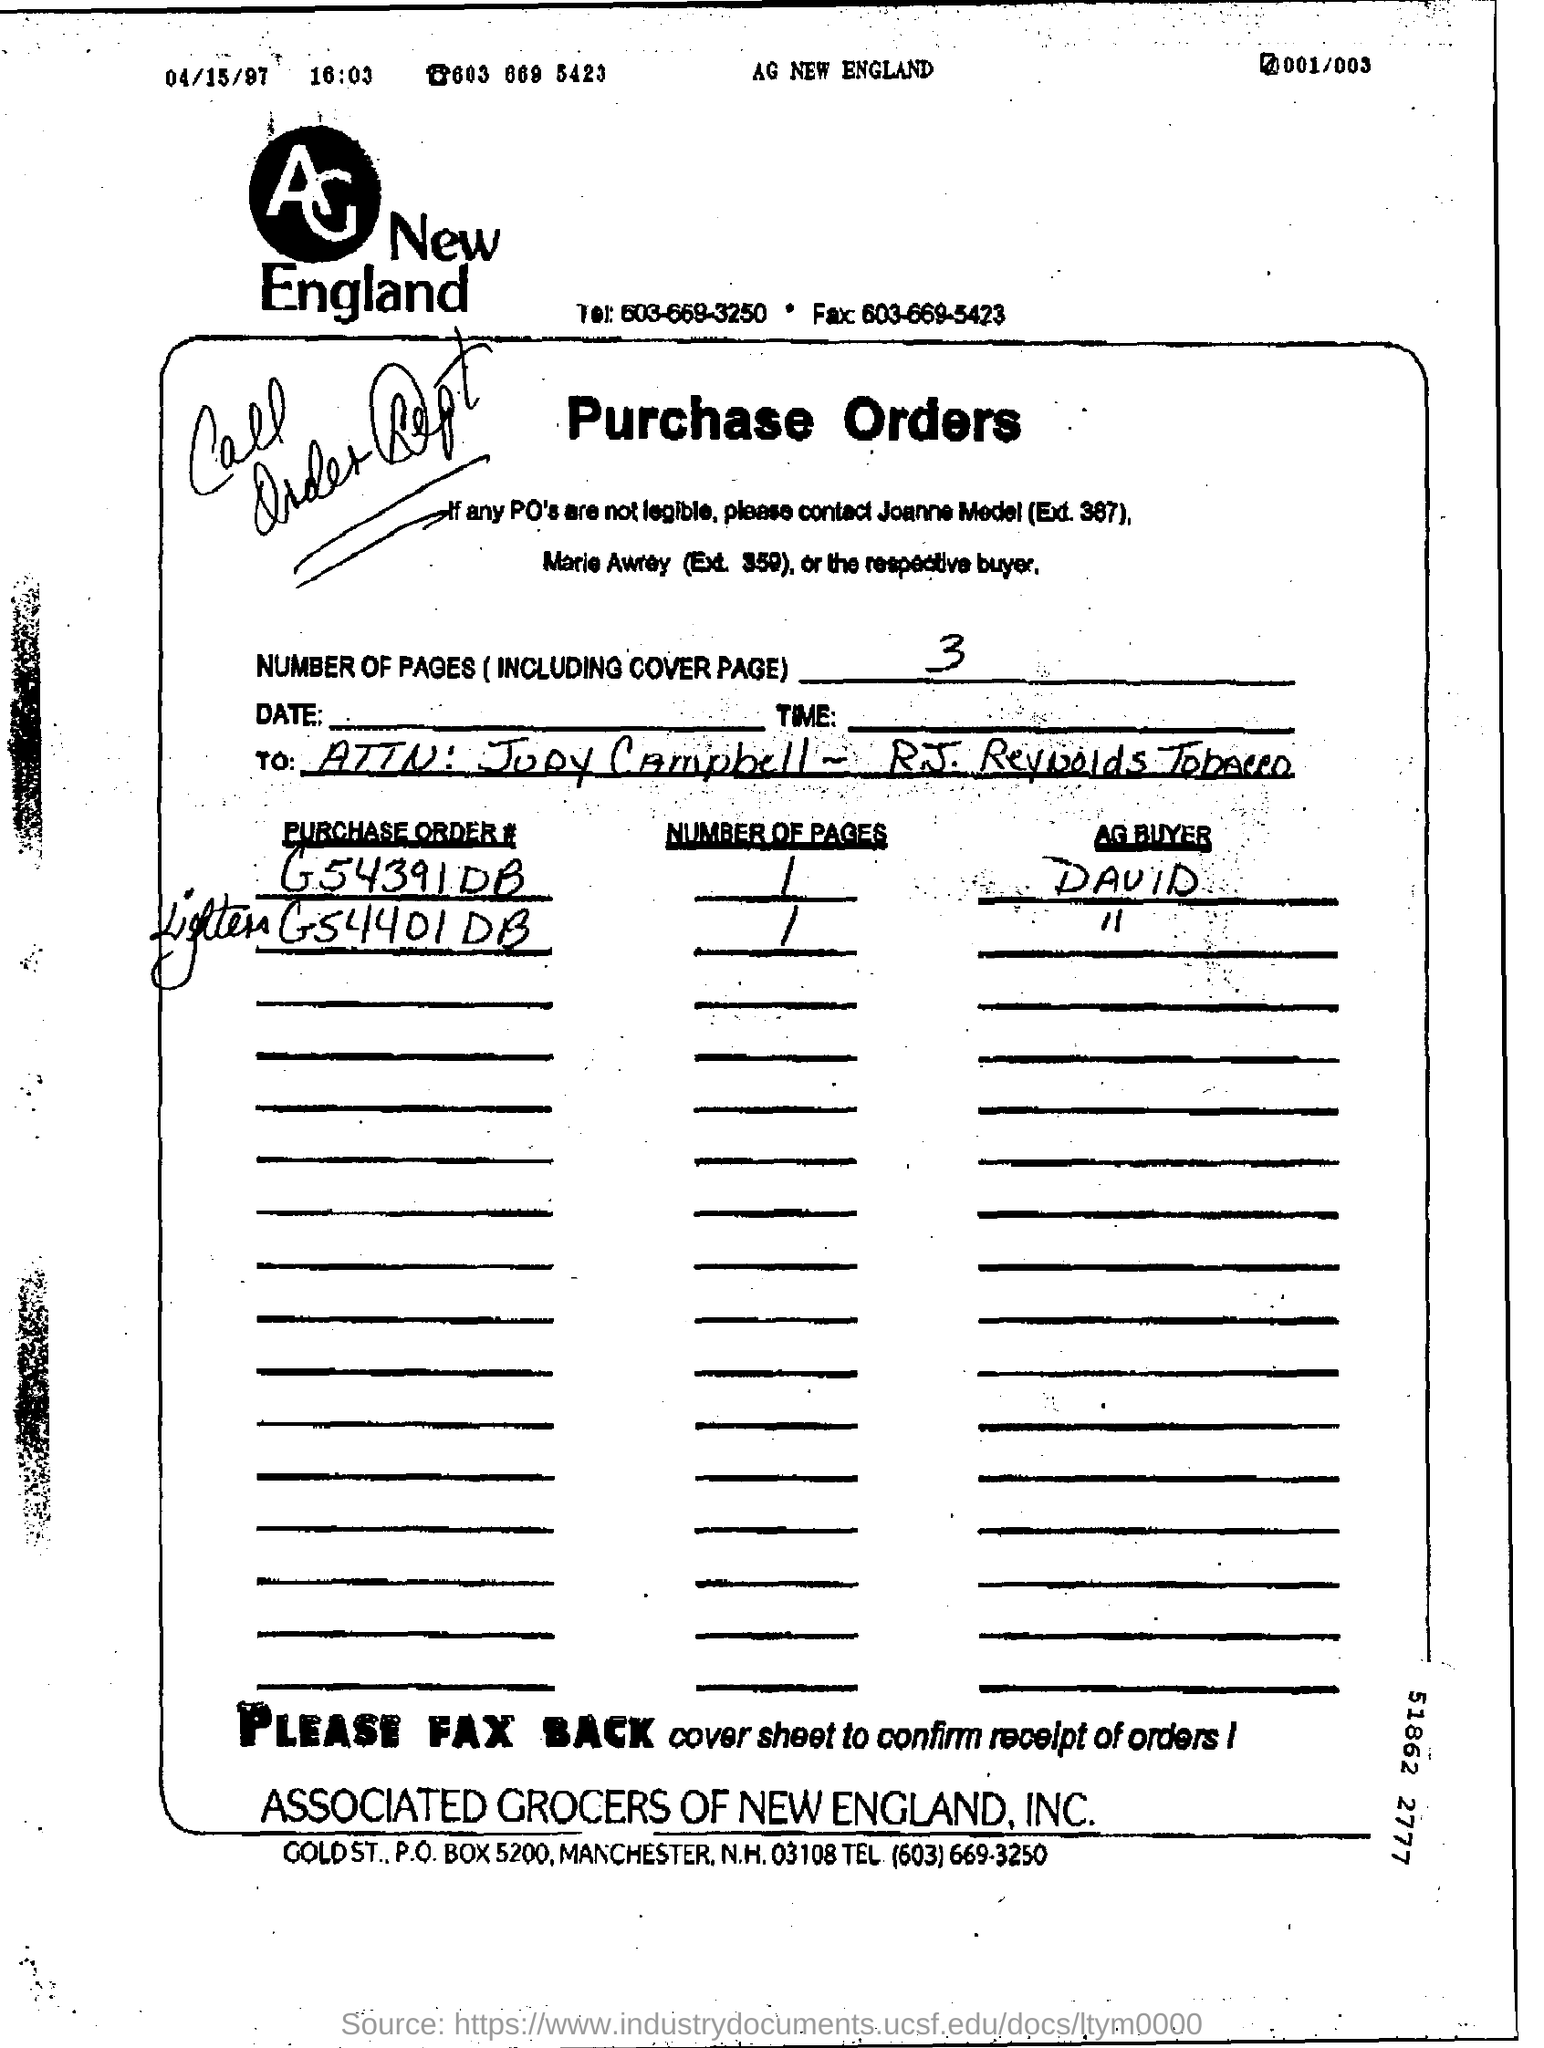Indicate a few pertinent items in this graphic. The person who is responsible for purchasing the purchase order number G54391DB is David. There are a total of 3 pages, including the cover page. 